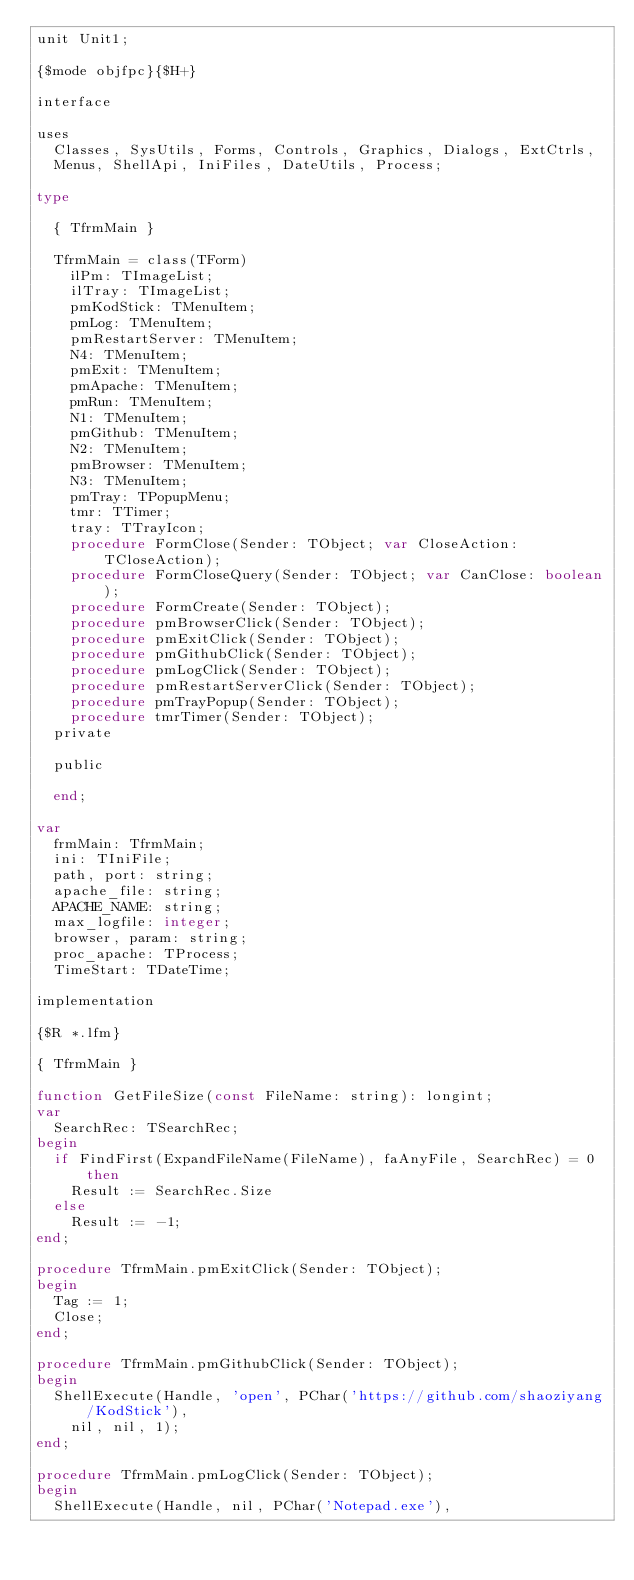<code> <loc_0><loc_0><loc_500><loc_500><_Pascal_>unit Unit1;

{$mode objfpc}{$H+}

interface

uses
  Classes, SysUtils, Forms, Controls, Graphics, Dialogs, ExtCtrls,
  Menus, ShellApi, IniFiles, DateUtils, Process;

type

  { TfrmMain }

  TfrmMain = class(TForm)
    ilPm: TImageList;
    ilTray: TImageList;
    pmKodStick: TMenuItem;
    pmLog: TMenuItem;
    pmRestartServer: TMenuItem;
    N4: TMenuItem;
    pmExit: TMenuItem;
    pmApache: TMenuItem;
    pmRun: TMenuItem;
    N1: TMenuItem;
    pmGithub: TMenuItem;
    N2: TMenuItem;
    pmBrowser: TMenuItem;
    N3: TMenuItem;
    pmTray: TPopupMenu;
    tmr: TTimer;
    tray: TTrayIcon;
    procedure FormClose(Sender: TObject; var CloseAction: TCloseAction);
    procedure FormCloseQuery(Sender: TObject; var CanClose: boolean);
    procedure FormCreate(Sender: TObject);
    procedure pmBrowserClick(Sender: TObject);
    procedure pmExitClick(Sender: TObject);
    procedure pmGithubClick(Sender: TObject);
    procedure pmLogClick(Sender: TObject);
    procedure pmRestartServerClick(Sender: TObject);
    procedure pmTrayPopup(Sender: TObject);
    procedure tmrTimer(Sender: TObject);
  private

  public

  end;

var
  frmMain: TfrmMain;
  ini: TIniFile;
  path, port: string;
  apache_file: string;
  APACHE_NAME: string;
  max_logfile: integer;
  browser, param: string;
  proc_apache: TProcess;
  TimeStart: TDateTime;

implementation

{$R *.lfm}

{ TfrmMain }

function GetFileSize(const FileName: string): longint;
var
  SearchRec: TSearchRec;
begin
  if FindFirst(ExpandFileName(FileName), faAnyFile, SearchRec) = 0 then
    Result := SearchRec.Size
  else
    Result := -1;
end;

procedure TfrmMain.pmExitClick(Sender: TObject);
begin
  Tag := 1;
  Close;
end;

procedure TfrmMain.pmGithubClick(Sender: TObject);
begin
  ShellExecute(Handle, 'open', PChar('https://github.com/shaoziyang/KodStick'),
    nil, nil, 1);
end;

procedure TfrmMain.pmLogClick(Sender: TObject);
begin
  ShellExecute(Handle, nil, PChar('Notepad.exe'),</code> 